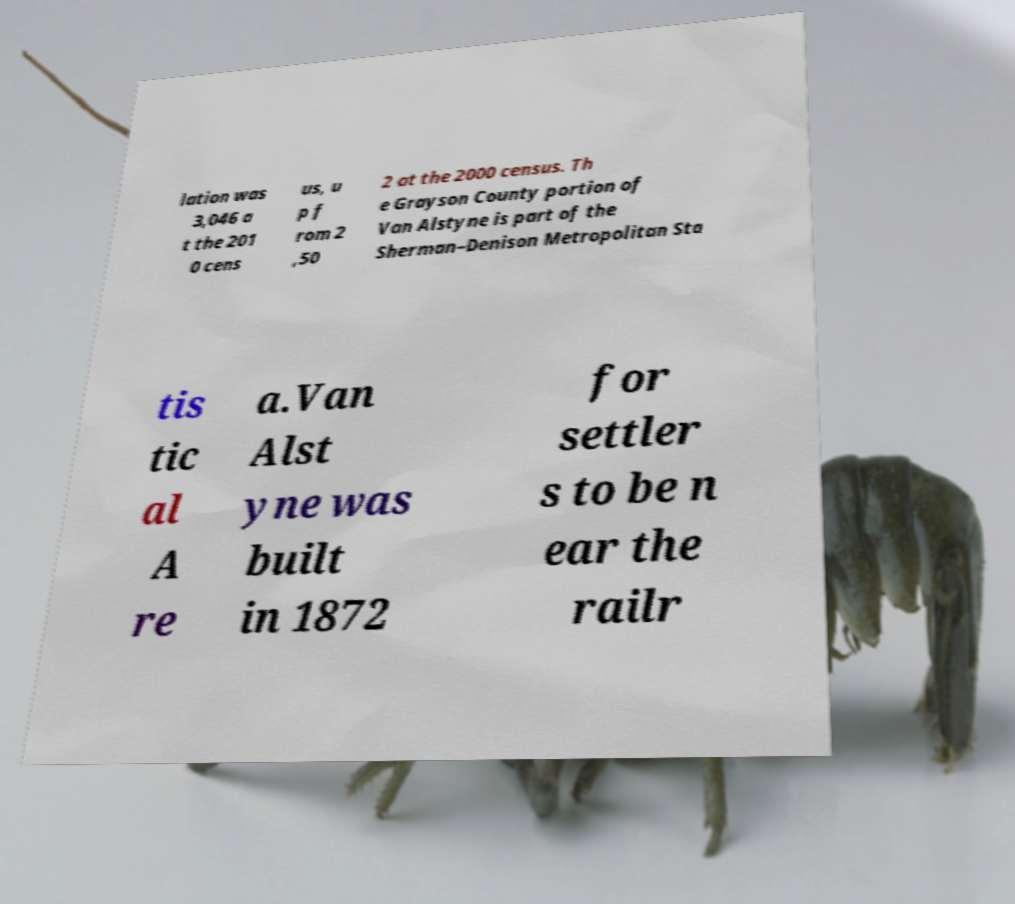Please read and relay the text visible in this image. What does it say? lation was 3,046 a t the 201 0 cens us, u p f rom 2 ,50 2 at the 2000 census. Th e Grayson County portion of Van Alstyne is part of the Sherman–Denison Metropolitan Sta tis tic al A re a.Van Alst yne was built in 1872 for settler s to be n ear the railr 